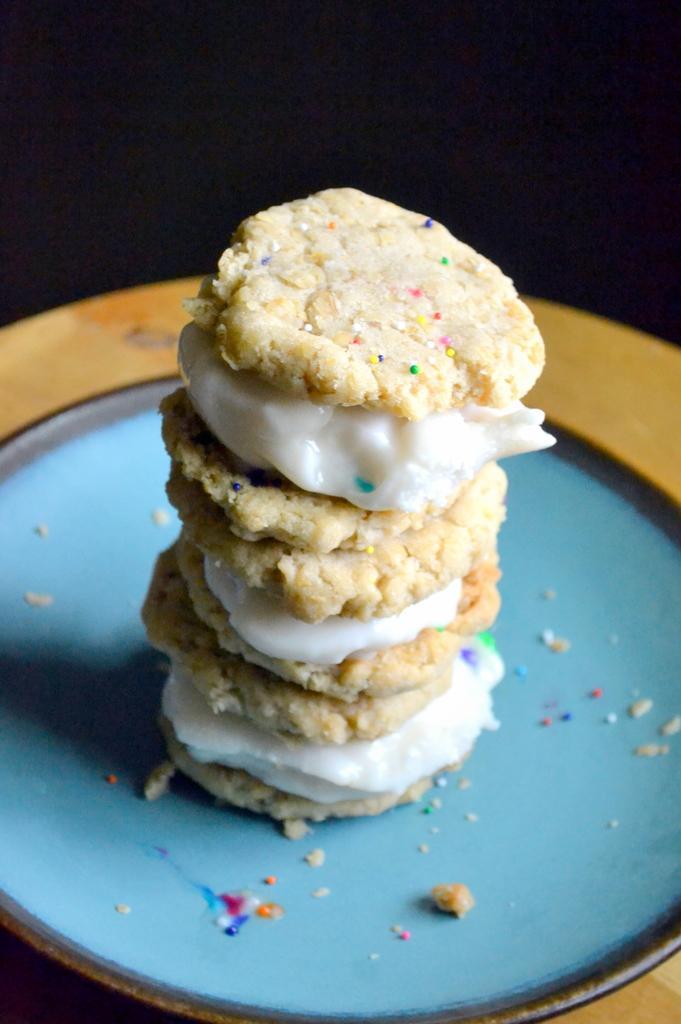Describe this image in one or two sentences. In this image there is food on the plate, there is plate on a wooden surface, the background of the image is dark. 